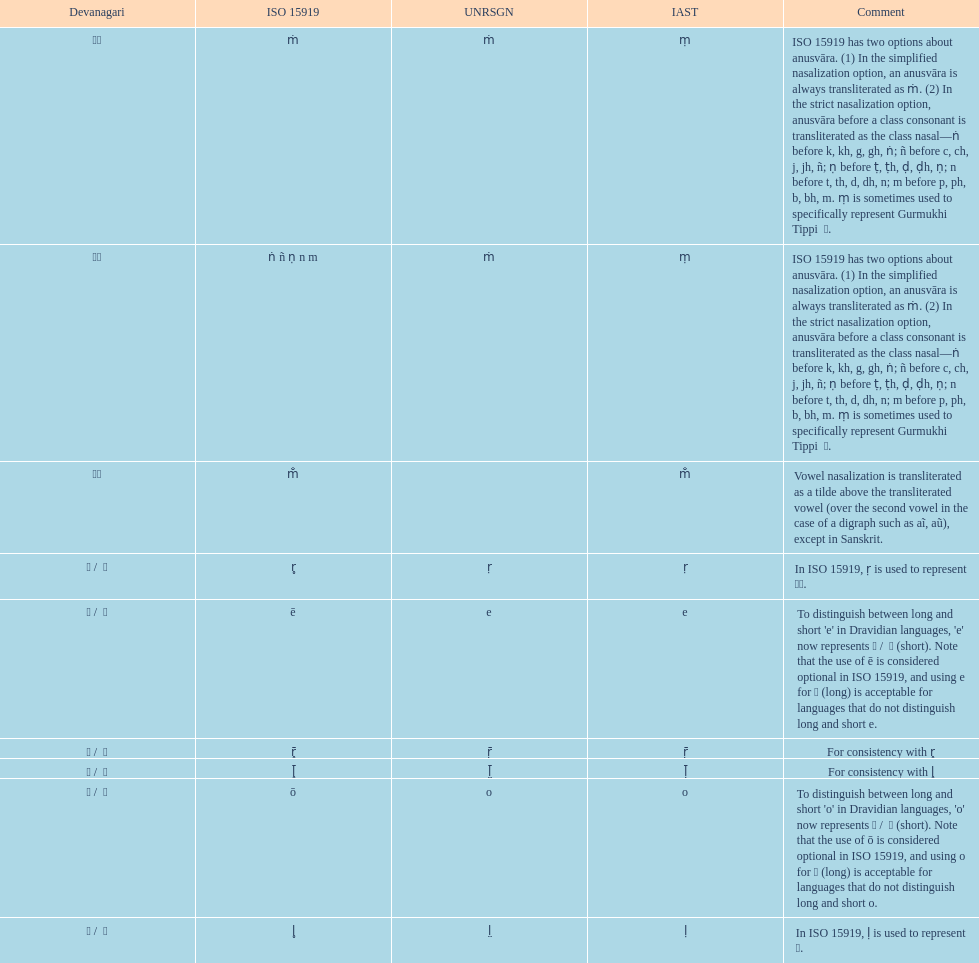How many total options are there about anusvara? 2. 